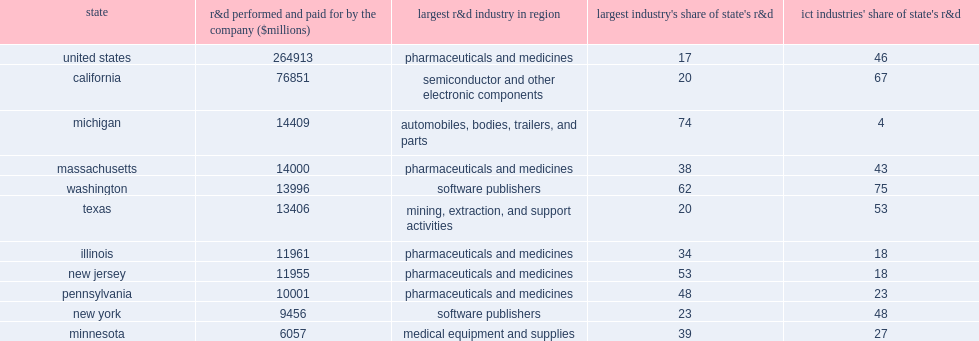How many percent did automobile manufacturers account of michigan's total? 74.0. How many percent did software publishers account of washington's total? 62.0. How many percent did the pharmaceutical industry account of new jersey's total? 53.0. How many percent did the pharmaceutical industry account of pennsylvania's total? 48.0. How many percent did the semiconductor and other electronic components industry (the largest industry in terms of r&d in california) account of california's business r&d? 20.0. How many percent did all information and communication technology (ict) industries combined account of the state's business r&d? 67.0. 